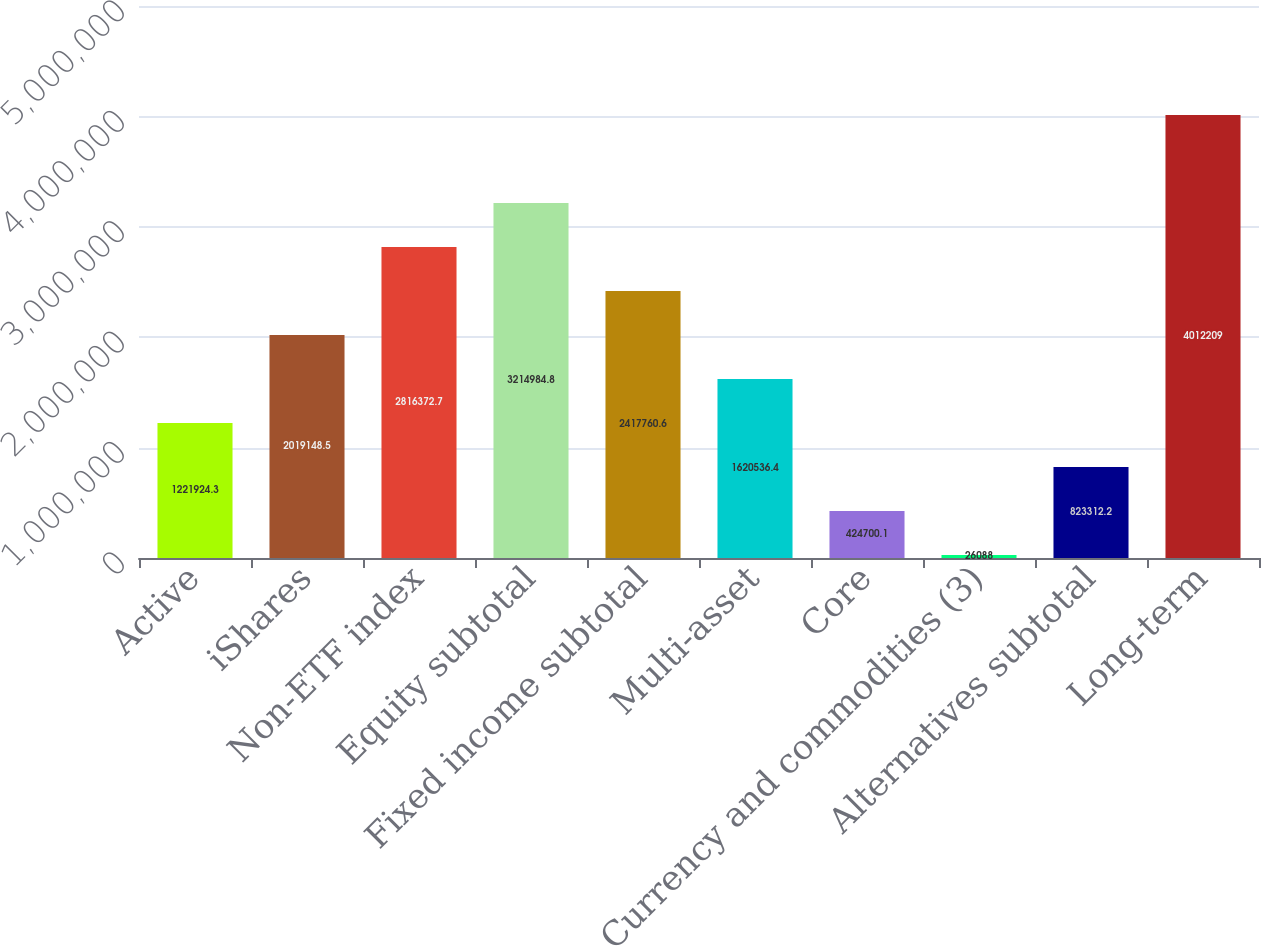Convert chart to OTSL. <chart><loc_0><loc_0><loc_500><loc_500><bar_chart><fcel>Active<fcel>iShares<fcel>Non-ETF index<fcel>Equity subtotal<fcel>Fixed income subtotal<fcel>Multi-asset<fcel>Core<fcel>Currency and commodities (3)<fcel>Alternatives subtotal<fcel>Long-term<nl><fcel>1.22192e+06<fcel>2.01915e+06<fcel>2.81637e+06<fcel>3.21498e+06<fcel>2.41776e+06<fcel>1.62054e+06<fcel>424700<fcel>26088<fcel>823312<fcel>4.01221e+06<nl></chart> 